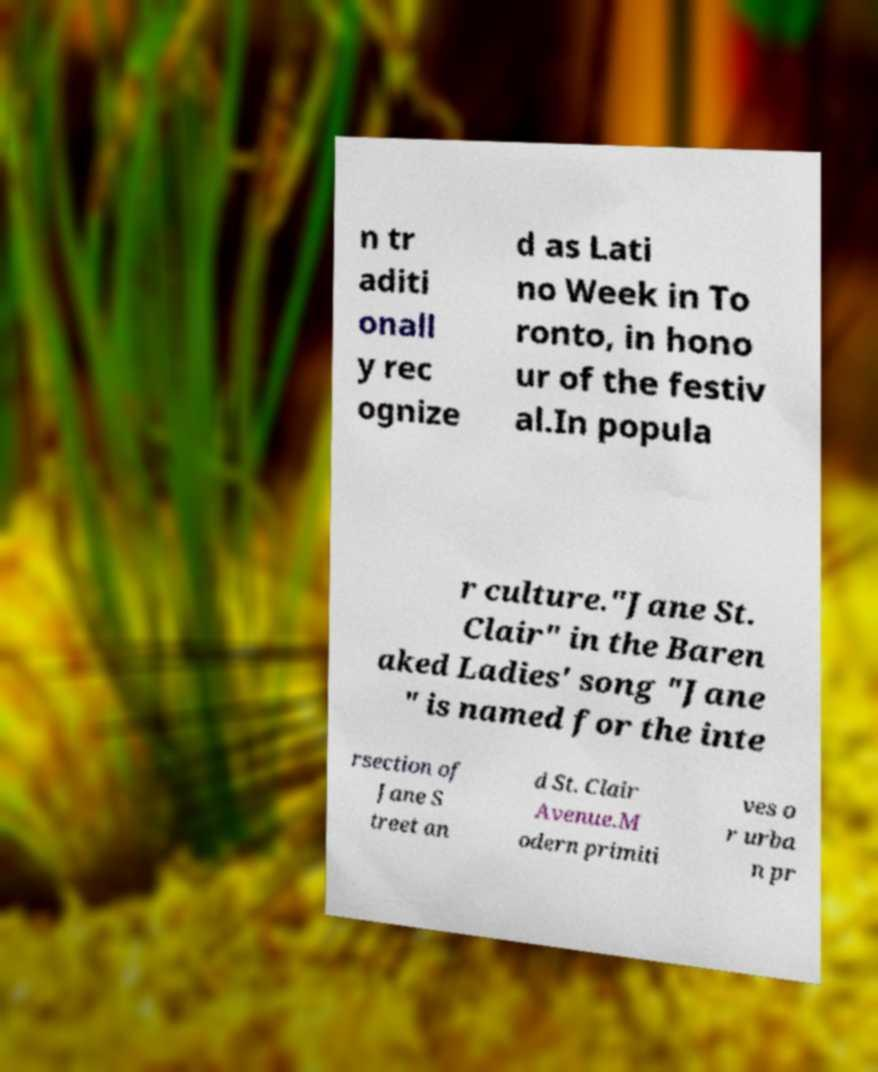Can you accurately transcribe the text from the provided image for me? n tr aditi onall y rec ognize d as Lati no Week in To ronto, in hono ur of the festiv al.In popula r culture."Jane St. Clair" in the Baren aked Ladies' song "Jane " is named for the inte rsection of Jane S treet an d St. Clair Avenue.M odern primiti ves o r urba n pr 